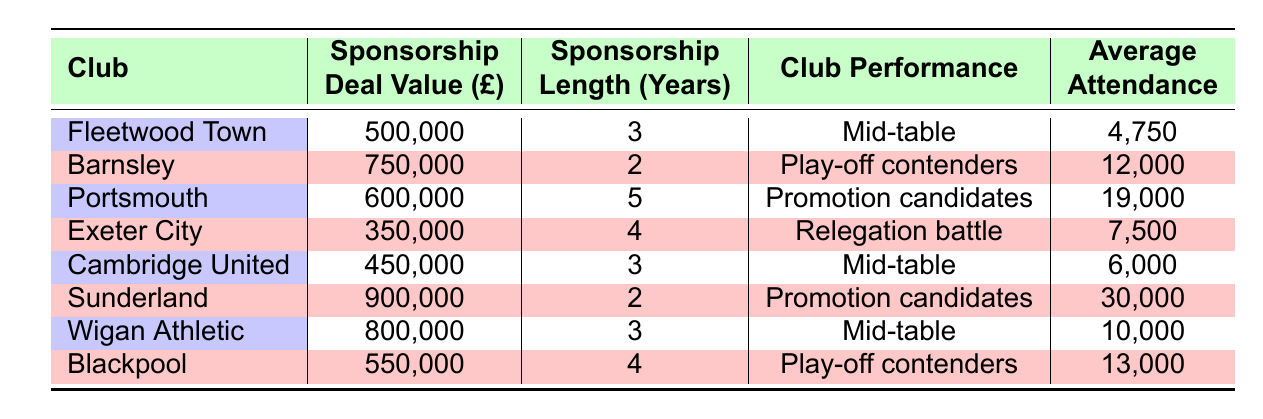What is the sponsorship deal value of Sunderland? Sunderland's sponsorship deal value is directly listed in the table. It shows 900,000.
Answer: 900,000 Which club has the highest average attendance? To find the highest average attendance, I compare the values in the average attendance column. Sunderland has the highest at 30,000.
Answer: Sunderland What is the average sponsorship deal value for all clubs listed? I add the sponsorship deal values: 500,000 + 750,000 + 600,000 + 350,000 + 450,000 + 900,000 + 800,000 + 550,000 = 4,800,000. Then divide by 8 (the number of clubs), yielding an average of 600,000.
Answer: 600,000 Is Exeter City a promotion candidate based on their club performance? I look at the club performance of Exeter City listed in the table, which states "Relegation battle." Therefore, the answer is no.
Answer: No How many clubs have a sponsorship length of 3 years? I count the clubs that have a sponsorship length of 3 years by examining the relevant column: Fleetwood Town, Cambridge United, and Wigan Athletic all have a sponsorship length of 3 years, making it a total of 3.
Answer: 3 What is the difference in average attendance between Portsmouth and Fleetwood Town? Portsmouth has an average attendance of 19,000 while Fleetwood Town has 4,750. To find the difference, I subtract 4,750 from 19,000: 19,000 - 4,750 = 14,250.
Answer: 14,250 Are any clubs in a relegation battle? I check the club performance of all clubs and find that Exeter City is the only club listed in a "Relegation battle." Thus, the answer is yes.
Answer: Yes Which club has a sponsorship deal less than 500,000? I look across the sponsorship deal values and see that the only deal less than 500,000 is Exeter City, listed at 350,000.
Answer: Exeter City 